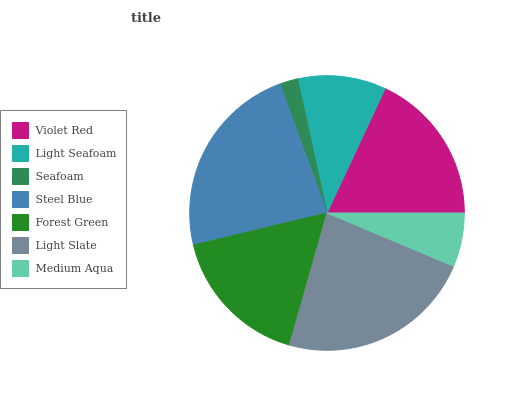Is Seafoam the minimum?
Answer yes or no. Yes. Is Steel Blue the maximum?
Answer yes or no. Yes. Is Light Seafoam the minimum?
Answer yes or no. No. Is Light Seafoam the maximum?
Answer yes or no. No. Is Violet Red greater than Light Seafoam?
Answer yes or no. Yes. Is Light Seafoam less than Violet Red?
Answer yes or no. Yes. Is Light Seafoam greater than Violet Red?
Answer yes or no. No. Is Violet Red less than Light Seafoam?
Answer yes or no. No. Is Forest Green the high median?
Answer yes or no. Yes. Is Forest Green the low median?
Answer yes or no. Yes. Is Seafoam the high median?
Answer yes or no. No. Is Seafoam the low median?
Answer yes or no. No. 